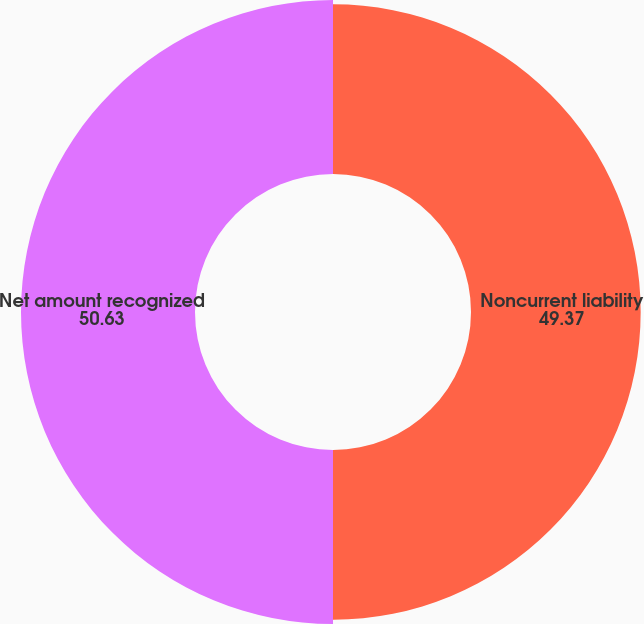Convert chart. <chart><loc_0><loc_0><loc_500><loc_500><pie_chart><fcel>Noncurrent liability<fcel>Net amount recognized<nl><fcel>49.37%<fcel>50.63%<nl></chart> 